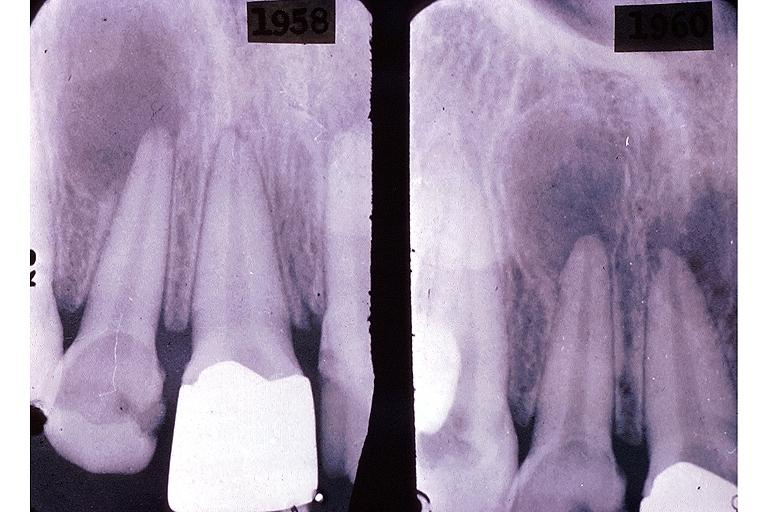what does this image show?
Answer the question using a single word or phrase. Periapical granuloma 